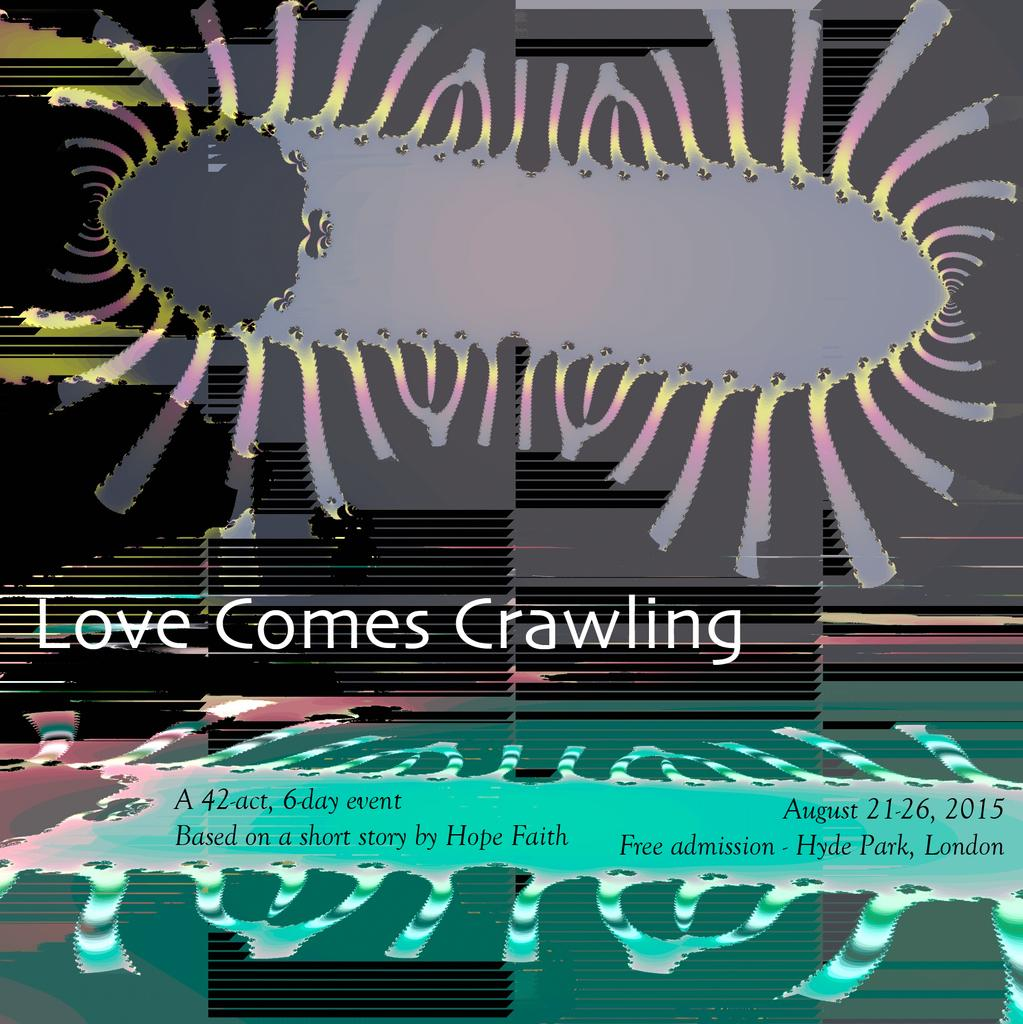Provide a one-sentence caption for the provided image. A sign that says Love Comes Crawling includes a picture of a bug. 